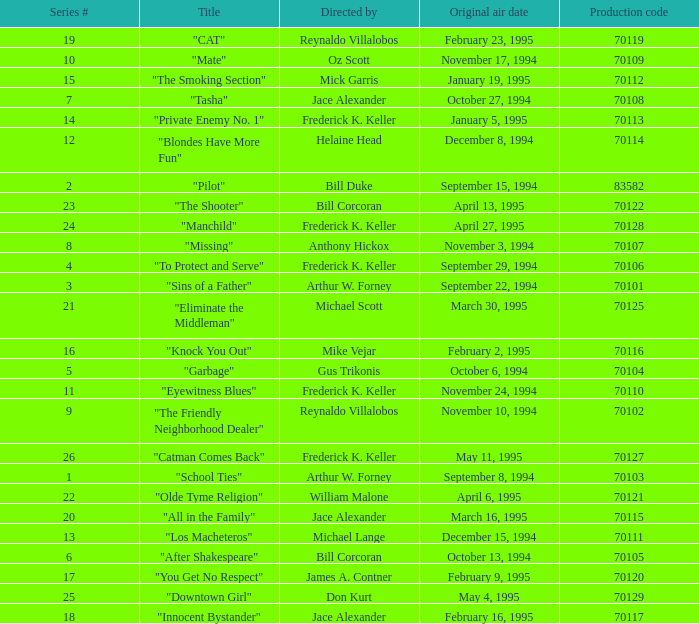What was the lowest production code value in series #10? 70109.0. 